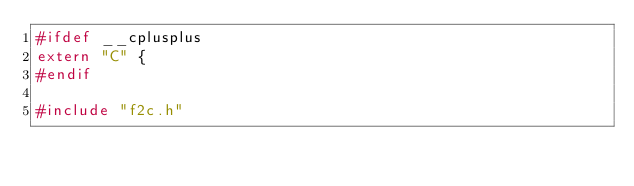Convert code to text. <code><loc_0><loc_0><loc_500><loc_500><_C_>#ifdef __cplusplus
extern "C" { 
#endif  

#include "f2c.h" 
</code> 